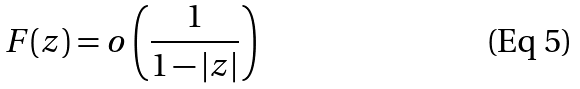<formula> <loc_0><loc_0><loc_500><loc_500>F ( z ) = o \left ( \frac { 1 } { 1 - | z | } \right )</formula> 